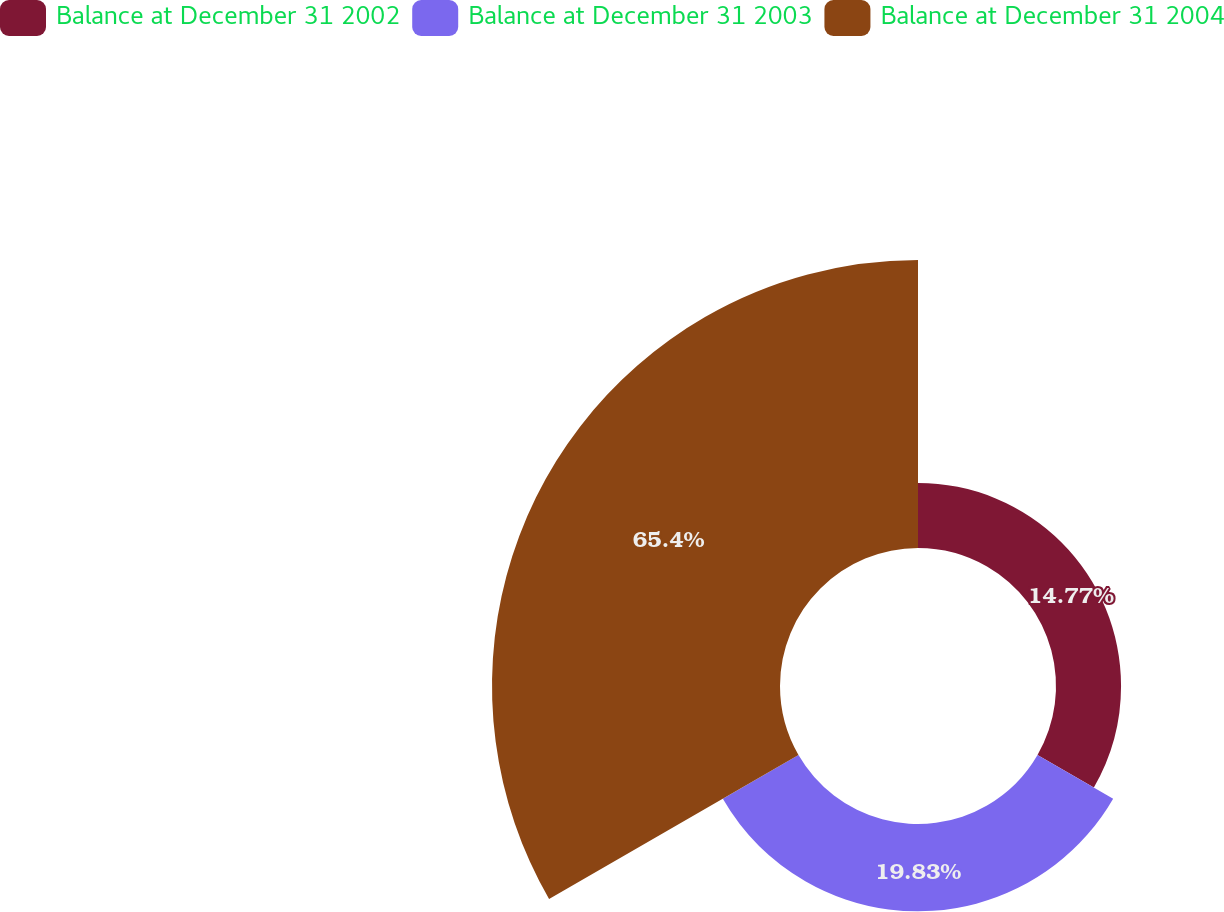<chart> <loc_0><loc_0><loc_500><loc_500><pie_chart><fcel>Balance at December 31 2002<fcel>Balance at December 31 2003<fcel>Balance at December 31 2004<nl><fcel>14.77%<fcel>19.83%<fcel>65.39%<nl></chart> 